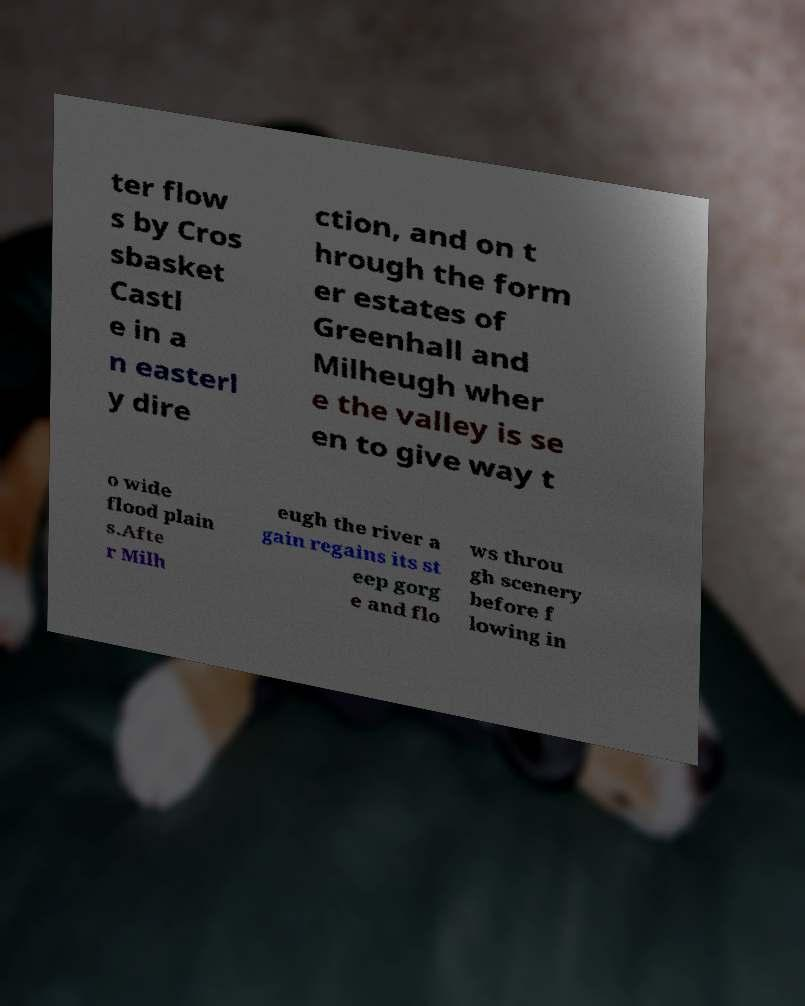Could you assist in decoding the text presented in this image and type it out clearly? ter flow s by Cros sbasket Castl e in a n easterl y dire ction, and on t hrough the form er estates of Greenhall and Milheugh wher e the valley is se en to give way t o wide flood plain s.Afte r Milh eugh the river a gain regains its st eep gorg e and flo ws throu gh scenery before f lowing in 